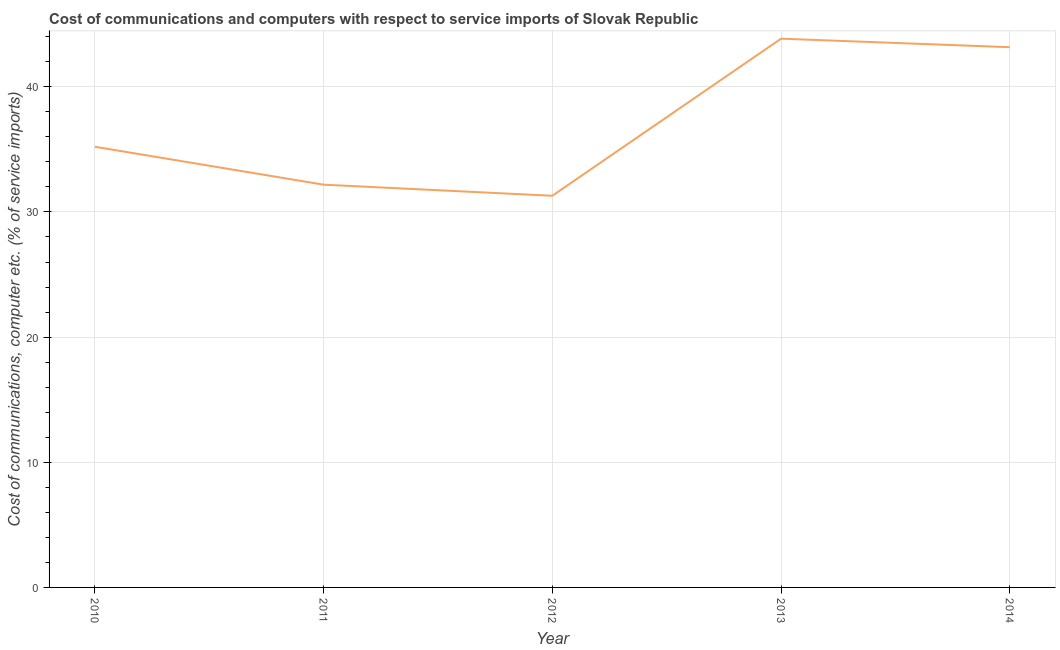What is the cost of communications and computer in 2010?
Keep it short and to the point. 35.21. Across all years, what is the maximum cost of communications and computer?
Offer a terse response. 43.85. Across all years, what is the minimum cost of communications and computer?
Provide a short and direct response. 31.29. What is the sum of the cost of communications and computer?
Your answer should be compact. 185.7. What is the difference between the cost of communications and computer in 2010 and 2011?
Make the answer very short. 3.03. What is the average cost of communications and computer per year?
Offer a very short reply. 37.14. What is the median cost of communications and computer?
Offer a terse response. 35.21. In how many years, is the cost of communications and computer greater than 12 %?
Provide a short and direct response. 5. Do a majority of the years between 2012 and 2014 (inclusive) have cost of communications and computer greater than 28 %?
Make the answer very short. Yes. What is the ratio of the cost of communications and computer in 2011 to that in 2014?
Provide a short and direct response. 0.75. Is the cost of communications and computer in 2011 less than that in 2014?
Offer a very short reply. Yes. What is the difference between the highest and the second highest cost of communications and computer?
Offer a terse response. 0.68. Is the sum of the cost of communications and computer in 2013 and 2014 greater than the maximum cost of communications and computer across all years?
Offer a terse response. Yes. What is the difference between the highest and the lowest cost of communications and computer?
Keep it short and to the point. 12.55. Does the cost of communications and computer monotonically increase over the years?
Offer a very short reply. No. What is the difference between two consecutive major ticks on the Y-axis?
Offer a very short reply. 10. Are the values on the major ticks of Y-axis written in scientific E-notation?
Offer a very short reply. No. Does the graph contain any zero values?
Keep it short and to the point. No. Does the graph contain grids?
Offer a very short reply. Yes. What is the title of the graph?
Your answer should be very brief. Cost of communications and computers with respect to service imports of Slovak Republic. What is the label or title of the Y-axis?
Provide a short and direct response. Cost of communications, computer etc. (% of service imports). What is the Cost of communications, computer etc. (% of service imports) of 2010?
Offer a terse response. 35.21. What is the Cost of communications, computer etc. (% of service imports) of 2011?
Ensure brevity in your answer.  32.18. What is the Cost of communications, computer etc. (% of service imports) in 2012?
Provide a succinct answer. 31.29. What is the Cost of communications, computer etc. (% of service imports) of 2013?
Make the answer very short. 43.85. What is the Cost of communications, computer etc. (% of service imports) of 2014?
Your answer should be very brief. 43.16. What is the difference between the Cost of communications, computer etc. (% of service imports) in 2010 and 2011?
Offer a terse response. 3.03. What is the difference between the Cost of communications, computer etc. (% of service imports) in 2010 and 2012?
Provide a succinct answer. 3.92. What is the difference between the Cost of communications, computer etc. (% of service imports) in 2010 and 2013?
Offer a very short reply. -8.64. What is the difference between the Cost of communications, computer etc. (% of service imports) in 2010 and 2014?
Offer a very short reply. -7.95. What is the difference between the Cost of communications, computer etc. (% of service imports) in 2011 and 2012?
Your answer should be very brief. 0.89. What is the difference between the Cost of communications, computer etc. (% of service imports) in 2011 and 2013?
Provide a short and direct response. -11.66. What is the difference between the Cost of communications, computer etc. (% of service imports) in 2011 and 2014?
Keep it short and to the point. -10.98. What is the difference between the Cost of communications, computer etc. (% of service imports) in 2012 and 2013?
Provide a succinct answer. -12.55. What is the difference between the Cost of communications, computer etc. (% of service imports) in 2012 and 2014?
Your answer should be very brief. -11.87. What is the difference between the Cost of communications, computer etc. (% of service imports) in 2013 and 2014?
Offer a terse response. 0.68. What is the ratio of the Cost of communications, computer etc. (% of service imports) in 2010 to that in 2011?
Ensure brevity in your answer.  1.09. What is the ratio of the Cost of communications, computer etc. (% of service imports) in 2010 to that in 2012?
Your response must be concise. 1.12. What is the ratio of the Cost of communications, computer etc. (% of service imports) in 2010 to that in 2013?
Your response must be concise. 0.8. What is the ratio of the Cost of communications, computer etc. (% of service imports) in 2010 to that in 2014?
Offer a very short reply. 0.82. What is the ratio of the Cost of communications, computer etc. (% of service imports) in 2011 to that in 2012?
Keep it short and to the point. 1.03. What is the ratio of the Cost of communications, computer etc. (% of service imports) in 2011 to that in 2013?
Offer a terse response. 0.73. What is the ratio of the Cost of communications, computer etc. (% of service imports) in 2011 to that in 2014?
Provide a short and direct response. 0.75. What is the ratio of the Cost of communications, computer etc. (% of service imports) in 2012 to that in 2013?
Your response must be concise. 0.71. What is the ratio of the Cost of communications, computer etc. (% of service imports) in 2012 to that in 2014?
Offer a very short reply. 0.72. What is the ratio of the Cost of communications, computer etc. (% of service imports) in 2013 to that in 2014?
Ensure brevity in your answer.  1.02. 